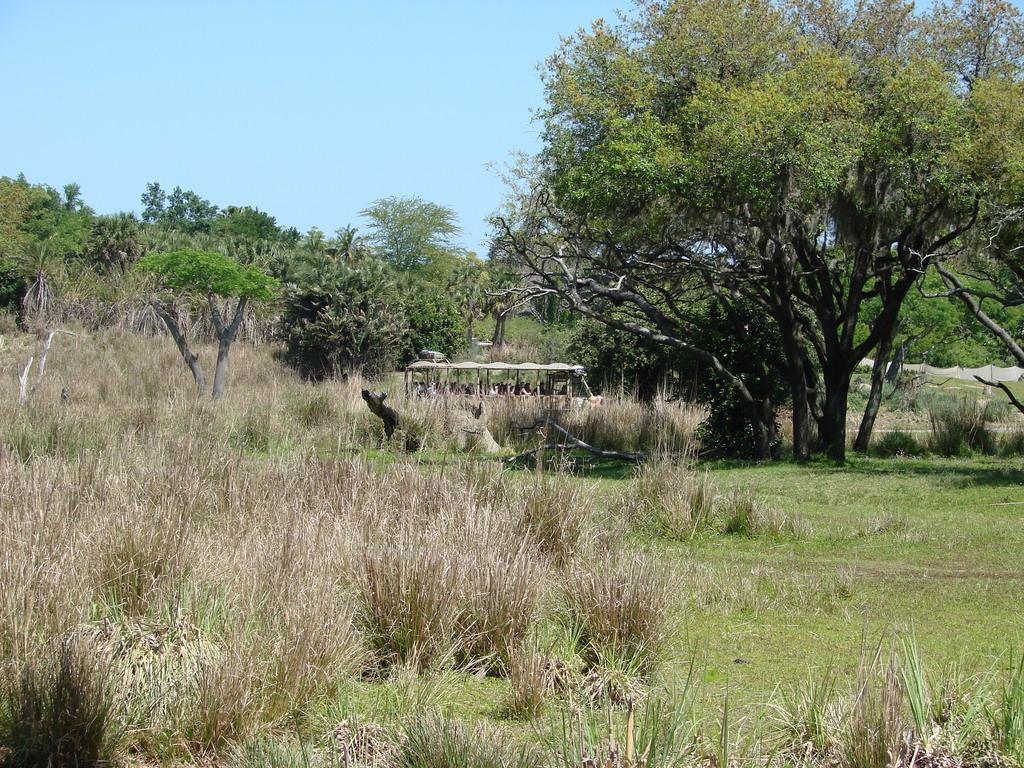Describe this image in one or two sentences. In this image there are trees and we can see a vehicle. At the bottom there is grass. In the background there is sky. 